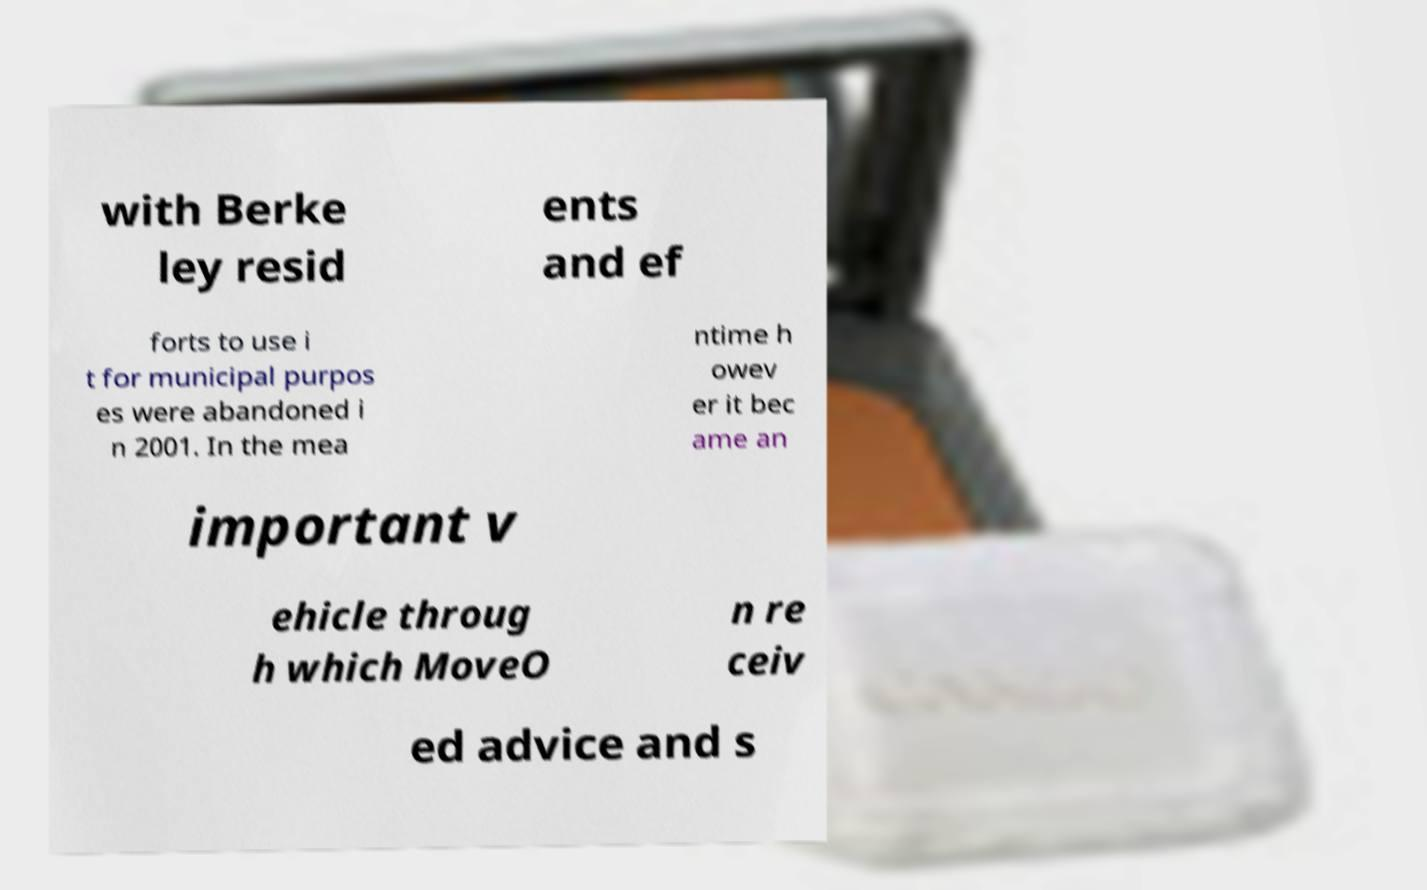Could you extract and type out the text from this image? with Berke ley resid ents and ef forts to use i t for municipal purpos es were abandoned i n 2001. In the mea ntime h owev er it bec ame an important v ehicle throug h which MoveO n re ceiv ed advice and s 